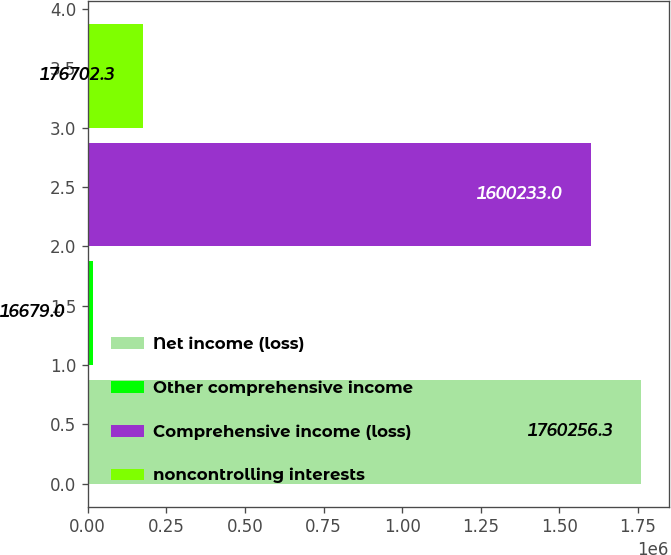<chart> <loc_0><loc_0><loc_500><loc_500><bar_chart><fcel>Net income (loss)<fcel>Other comprehensive income<fcel>Comprehensive income (loss)<fcel>noncontrolling interests<nl><fcel>1.76026e+06<fcel>16679<fcel>1.60023e+06<fcel>176702<nl></chart> 